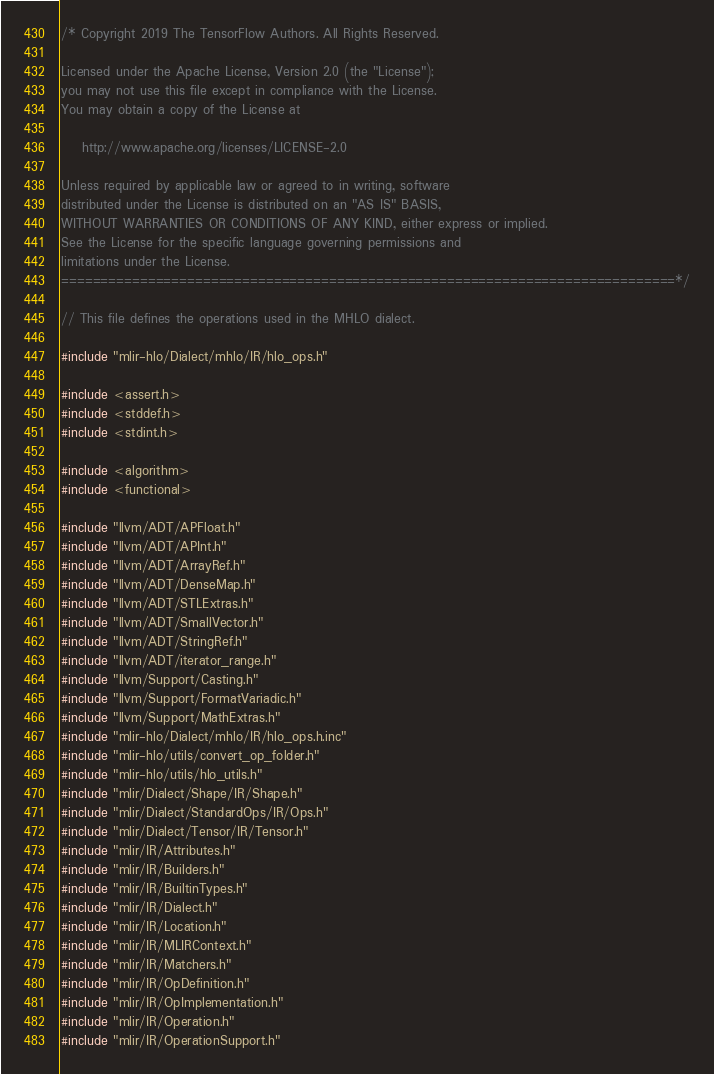<code> <loc_0><loc_0><loc_500><loc_500><_C++_>/* Copyright 2019 The TensorFlow Authors. All Rights Reserved.

Licensed under the Apache License, Version 2.0 (the "License");
you may not use this file except in compliance with the License.
You may obtain a copy of the License at

    http://www.apache.org/licenses/LICENSE-2.0

Unless required by applicable law or agreed to in writing, software
distributed under the License is distributed on an "AS IS" BASIS,
WITHOUT WARRANTIES OR CONDITIONS OF ANY KIND, either express or implied.
See the License for the specific language governing permissions and
limitations under the License.
==============================================================================*/

// This file defines the operations used in the MHLO dialect.

#include "mlir-hlo/Dialect/mhlo/IR/hlo_ops.h"

#include <assert.h>
#include <stddef.h>
#include <stdint.h>

#include <algorithm>
#include <functional>

#include "llvm/ADT/APFloat.h"
#include "llvm/ADT/APInt.h"
#include "llvm/ADT/ArrayRef.h"
#include "llvm/ADT/DenseMap.h"
#include "llvm/ADT/STLExtras.h"
#include "llvm/ADT/SmallVector.h"
#include "llvm/ADT/StringRef.h"
#include "llvm/ADT/iterator_range.h"
#include "llvm/Support/Casting.h"
#include "llvm/Support/FormatVariadic.h"
#include "llvm/Support/MathExtras.h"
#include "mlir-hlo/Dialect/mhlo/IR/hlo_ops.h.inc"
#include "mlir-hlo/utils/convert_op_folder.h"
#include "mlir-hlo/utils/hlo_utils.h"
#include "mlir/Dialect/Shape/IR/Shape.h"
#include "mlir/Dialect/StandardOps/IR/Ops.h"
#include "mlir/Dialect/Tensor/IR/Tensor.h"
#include "mlir/IR/Attributes.h"
#include "mlir/IR/Builders.h"
#include "mlir/IR/BuiltinTypes.h"
#include "mlir/IR/Dialect.h"
#include "mlir/IR/Location.h"
#include "mlir/IR/MLIRContext.h"
#include "mlir/IR/Matchers.h"
#include "mlir/IR/OpDefinition.h"
#include "mlir/IR/OpImplementation.h"
#include "mlir/IR/Operation.h"
#include "mlir/IR/OperationSupport.h"</code> 